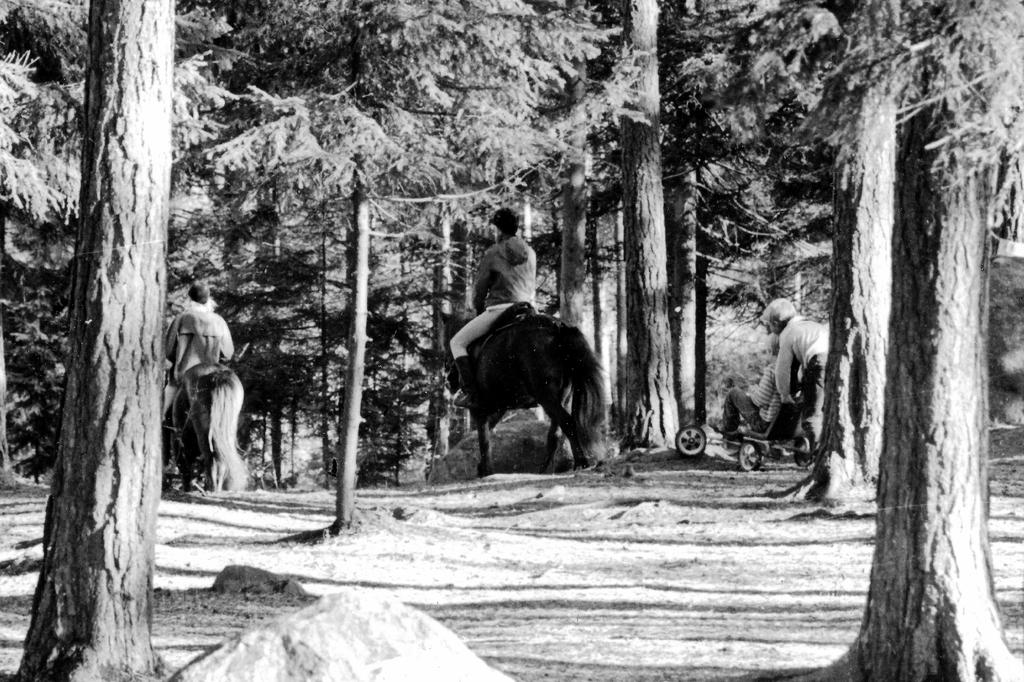What are the men in the image doing? The men in the image are riding horses. What is the guy in the trolley doing? The guy in the trolley is being transported by another person who is pushing the trolley. What can be seen in the background of the image? There is land and trees visible in the background of the image. What type of powder is being used by the men riding horses in the image? There is no mention of powder being used in the image; the men are simply riding horses. What kind of underwear is the person pushing the trolley wearing in the image? There is no information about the person's underwear in the image, as it is not visible or relevant to the scene. 